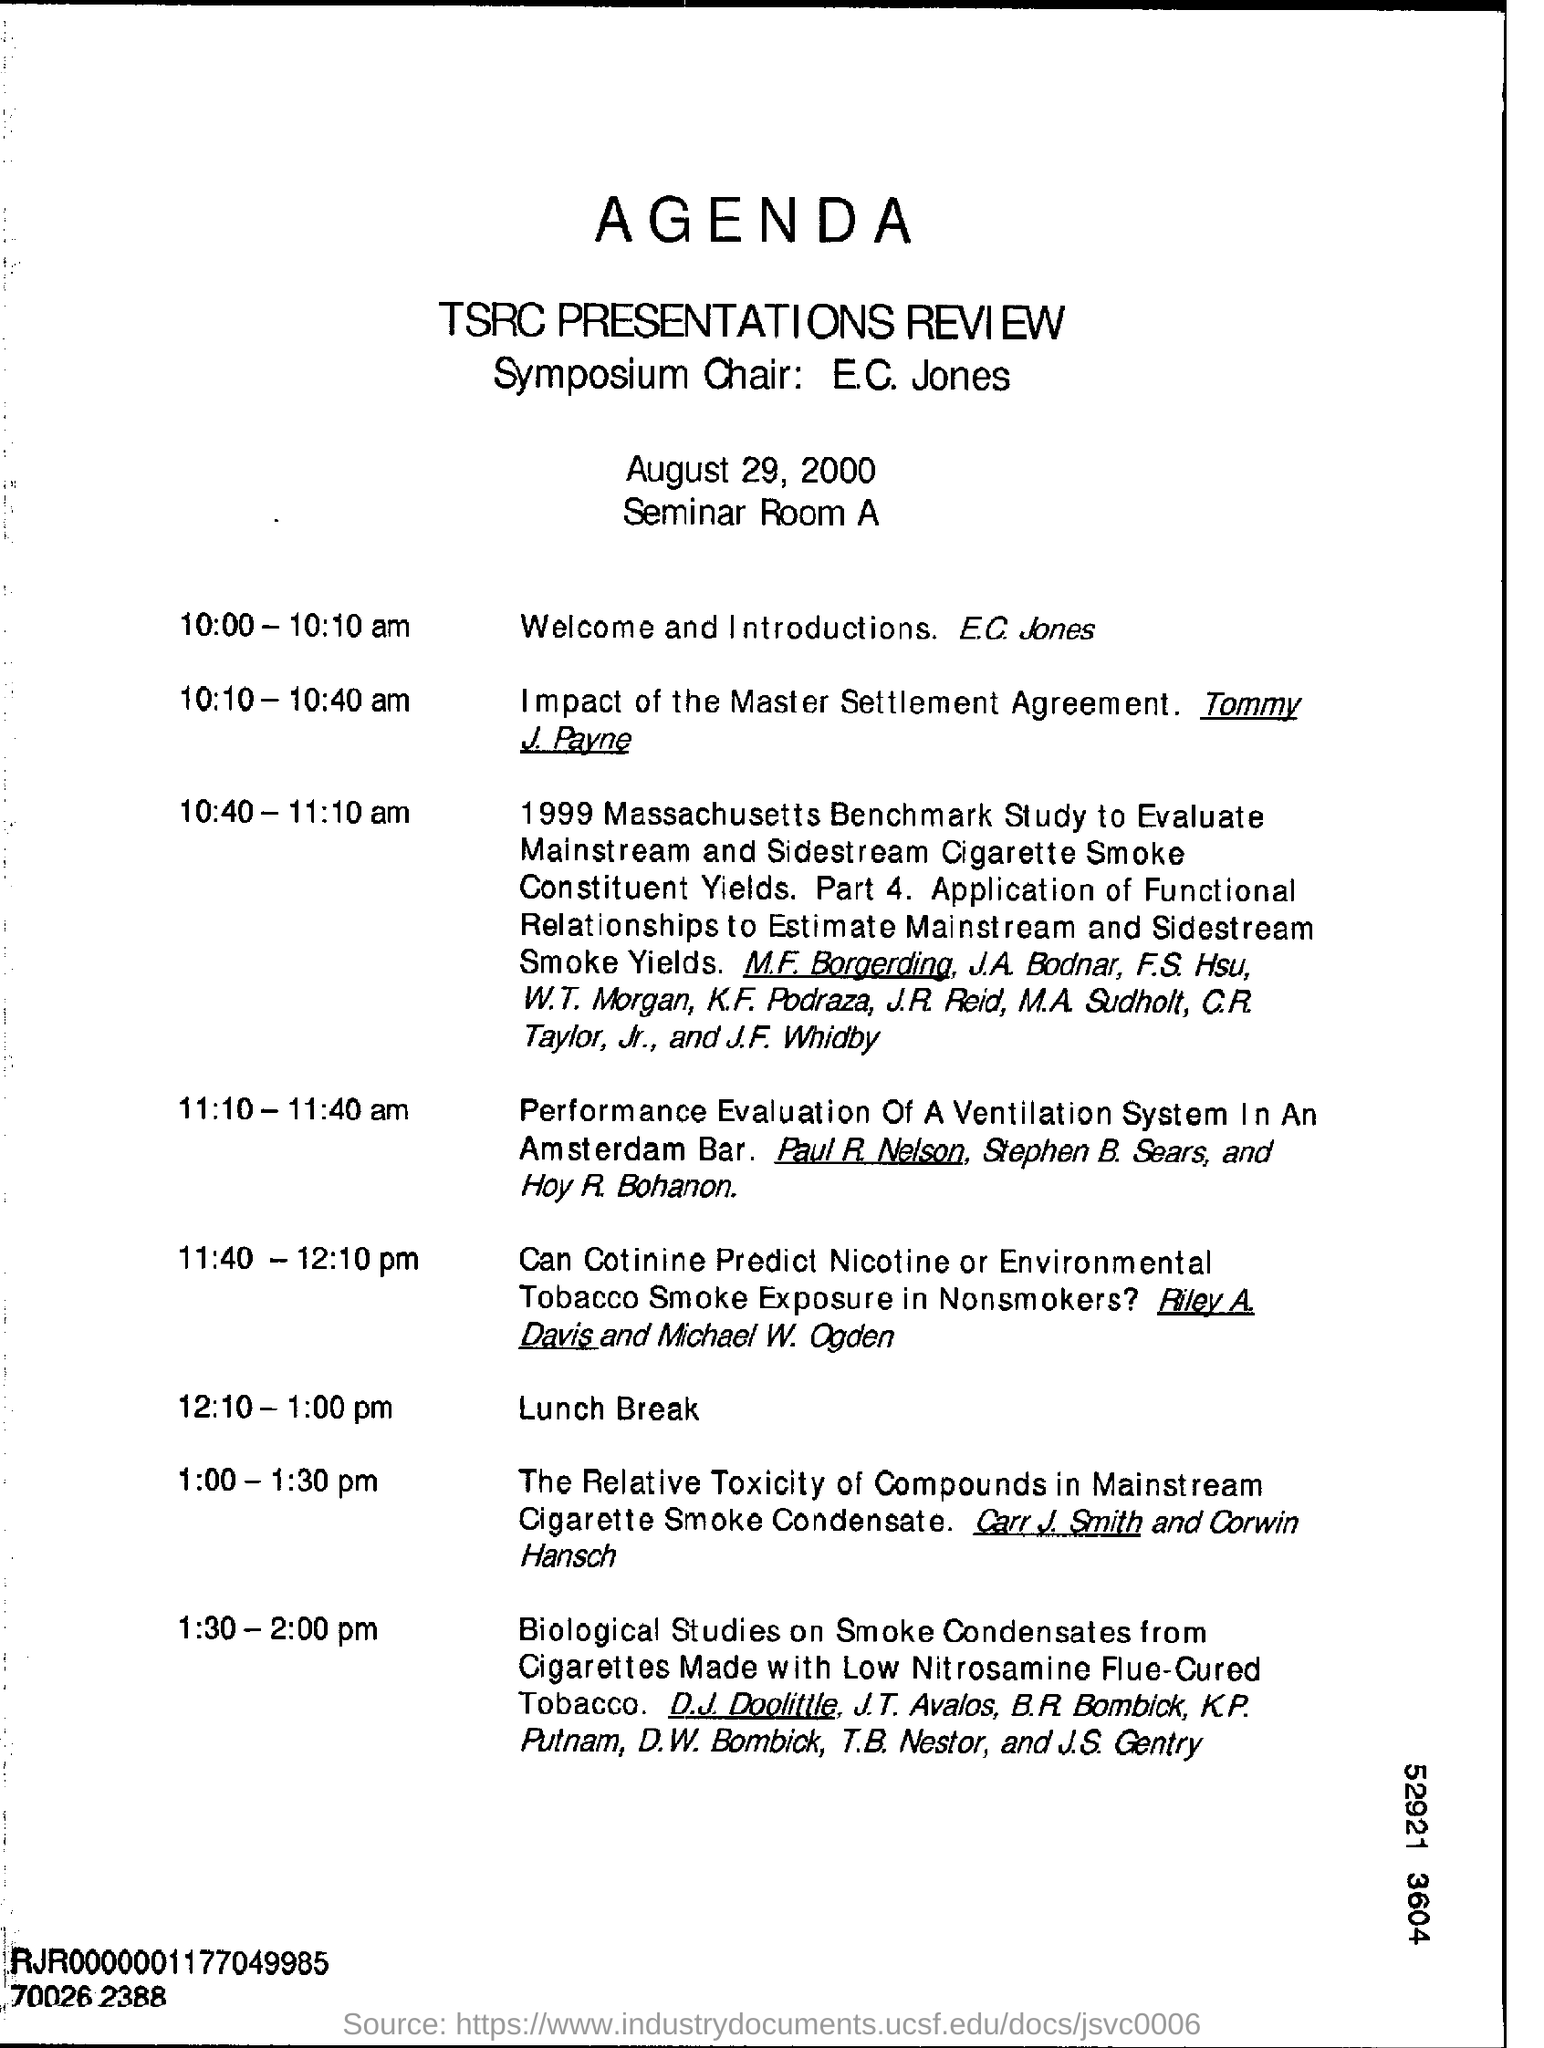Give some essential details in this illustration. The lunch break will commence at 12:10 pm. It has been announced that E.C. Jones will be delivering the welcome and introduction speech. The seminar was conducted on August 29, 2000. E.C. Jones' welcome and introductions are scheduled to take place from 10:00 - 10:10 am. 